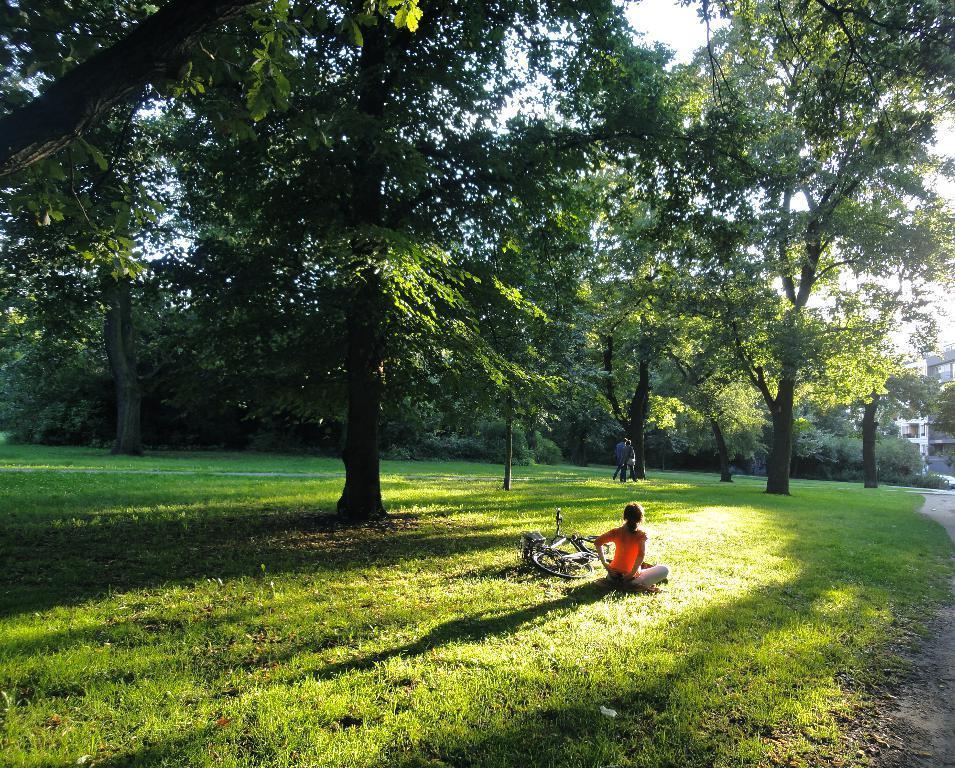Can you describe this image briefly? In this picture there are people on the right side of the image and there is a bicycle on the floor, on the grassland and there are trees and buildings in the background area of the image. 